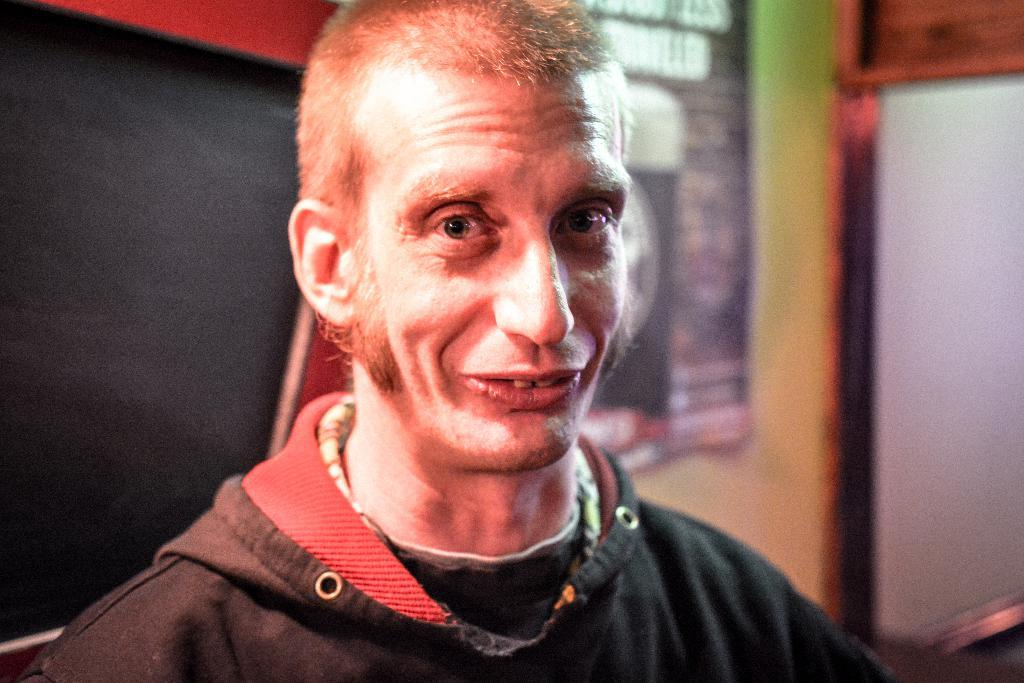What is the main subject of the image? There is a person's face in the front of the image. What can be seen behind the person's face? There is a wall in the background of the image. Are there any additional objects or features visible in the background? Yes, there is a poster visible in the background. What type of umbrella is the person holding in the image? There is no umbrella present in the image. What kind of hairstyle does the person have in the image? The image only shows the person's face, so it is not possible to determine their hairstyle. Is the person in the image a farmer? There is no information about the person's occupation in the image, so it cannot be determined if they are a farmer. 